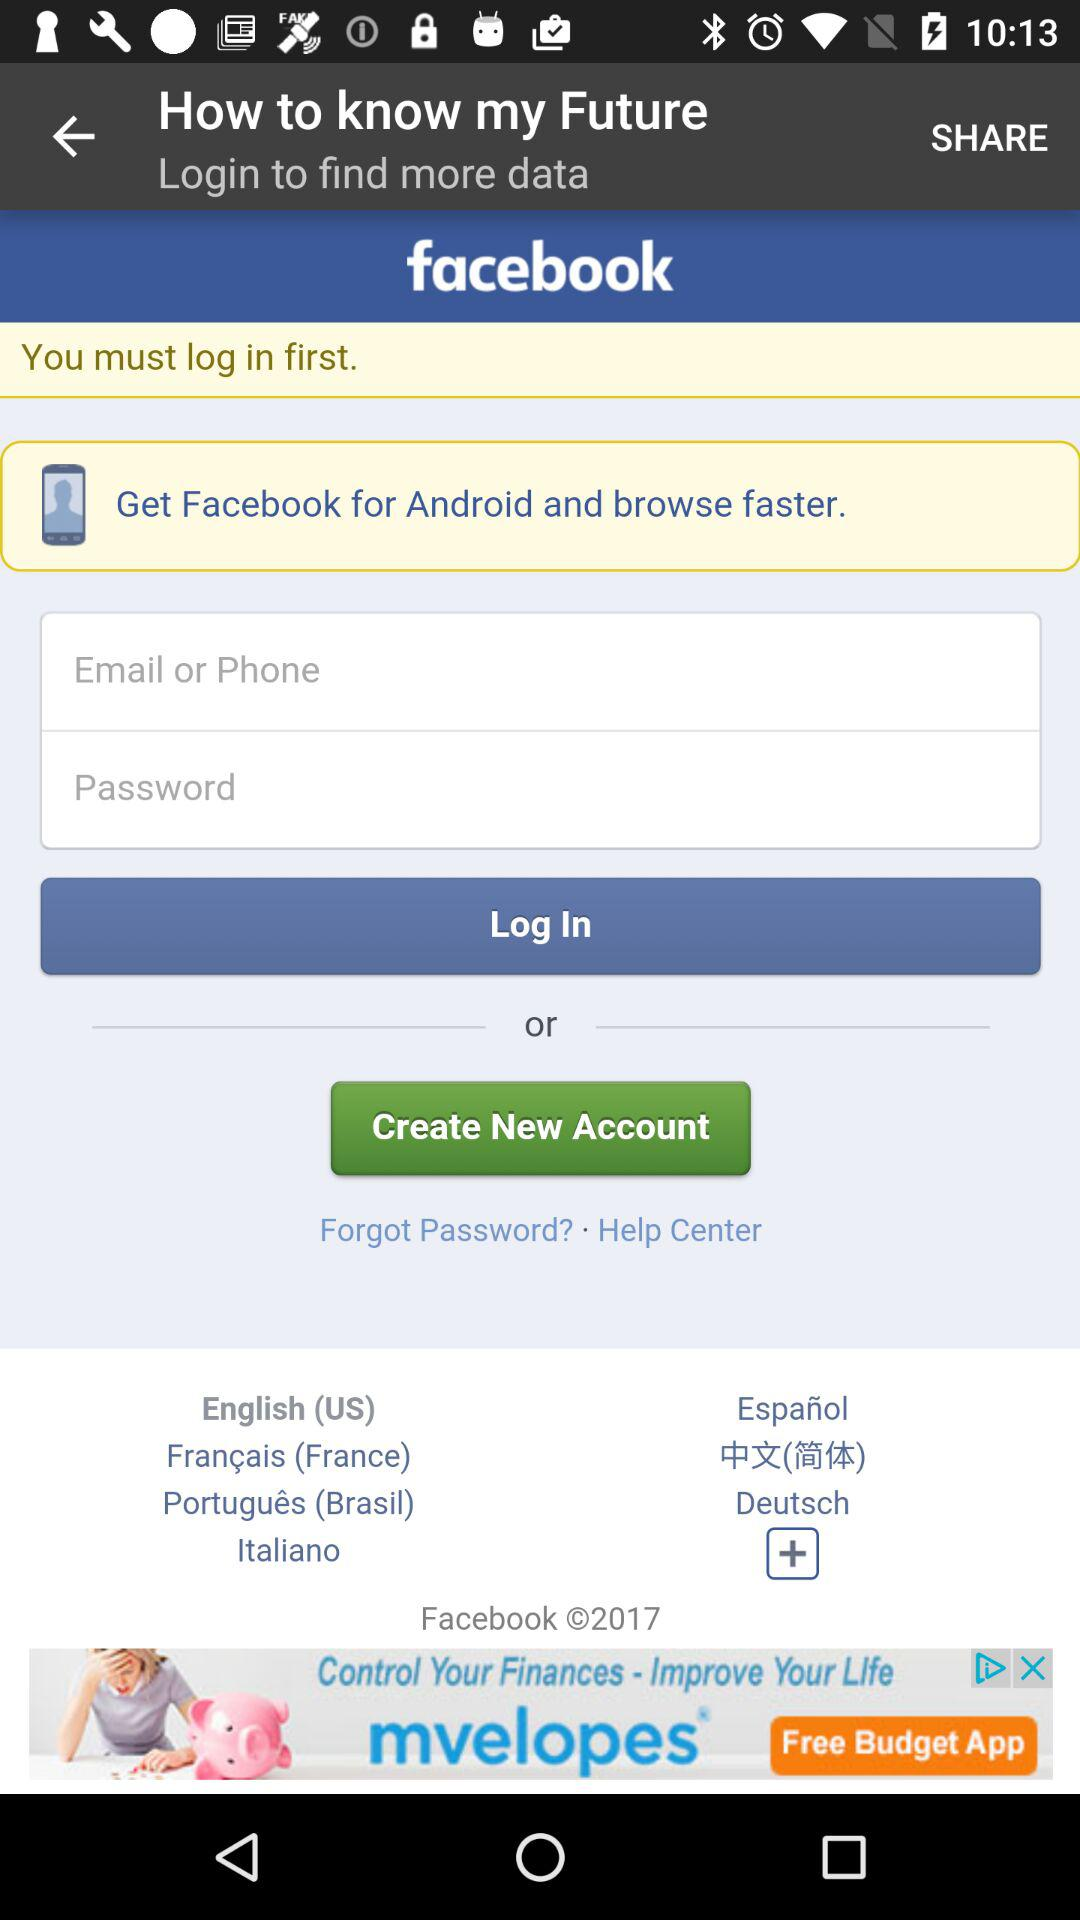What is the application name? The application name is "my Future". 